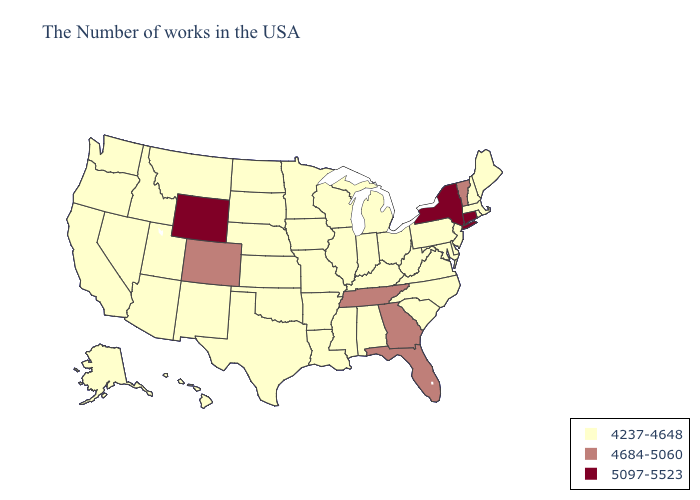Among the states that border Kentucky , does Tennessee have the lowest value?
Concise answer only. No. Name the states that have a value in the range 4684-5060?
Be succinct. Vermont, Florida, Georgia, Tennessee, Colorado. Name the states that have a value in the range 5097-5523?
Write a very short answer. Connecticut, New York, Wyoming. Name the states that have a value in the range 4684-5060?
Write a very short answer. Vermont, Florida, Georgia, Tennessee, Colorado. What is the highest value in the South ?
Be succinct. 4684-5060. Does Alabama have the lowest value in the USA?
Short answer required. Yes. What is the value of Arkansas?
Concise answer only. 4237-4648. Does Mississippi have the highest value in the South?
Write a very short answer. No. What is the value of Wisconsin?
Concise answer only. 4237-4648. Which states have the highest value in the USA?
Answer briefly. Connecticut, New York, Wyoming. Does Maine have the highest value in the Northeast?
Give a very brief answer. No. Name the states that have a value in the range 4684-5060?
Short answer required. Vermont, Florida, Georgia, Tennessee, Colorado. Does Florida have the highest value in the USA?
Concise answer only. No. What is the value of Arkansas?
Keep it brief. 4237-4648. 